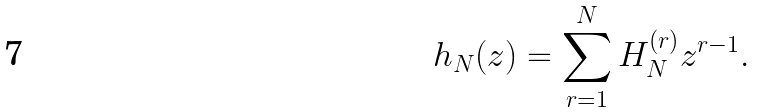<formula> <loc_0><loc_0><loc_500><loc_500>h _ { N } ( z ) = \sum _ { r = 1 } ^ { N } H _ { N } ^ { ( r ) } z ^ { r - 1 } .</formula> 